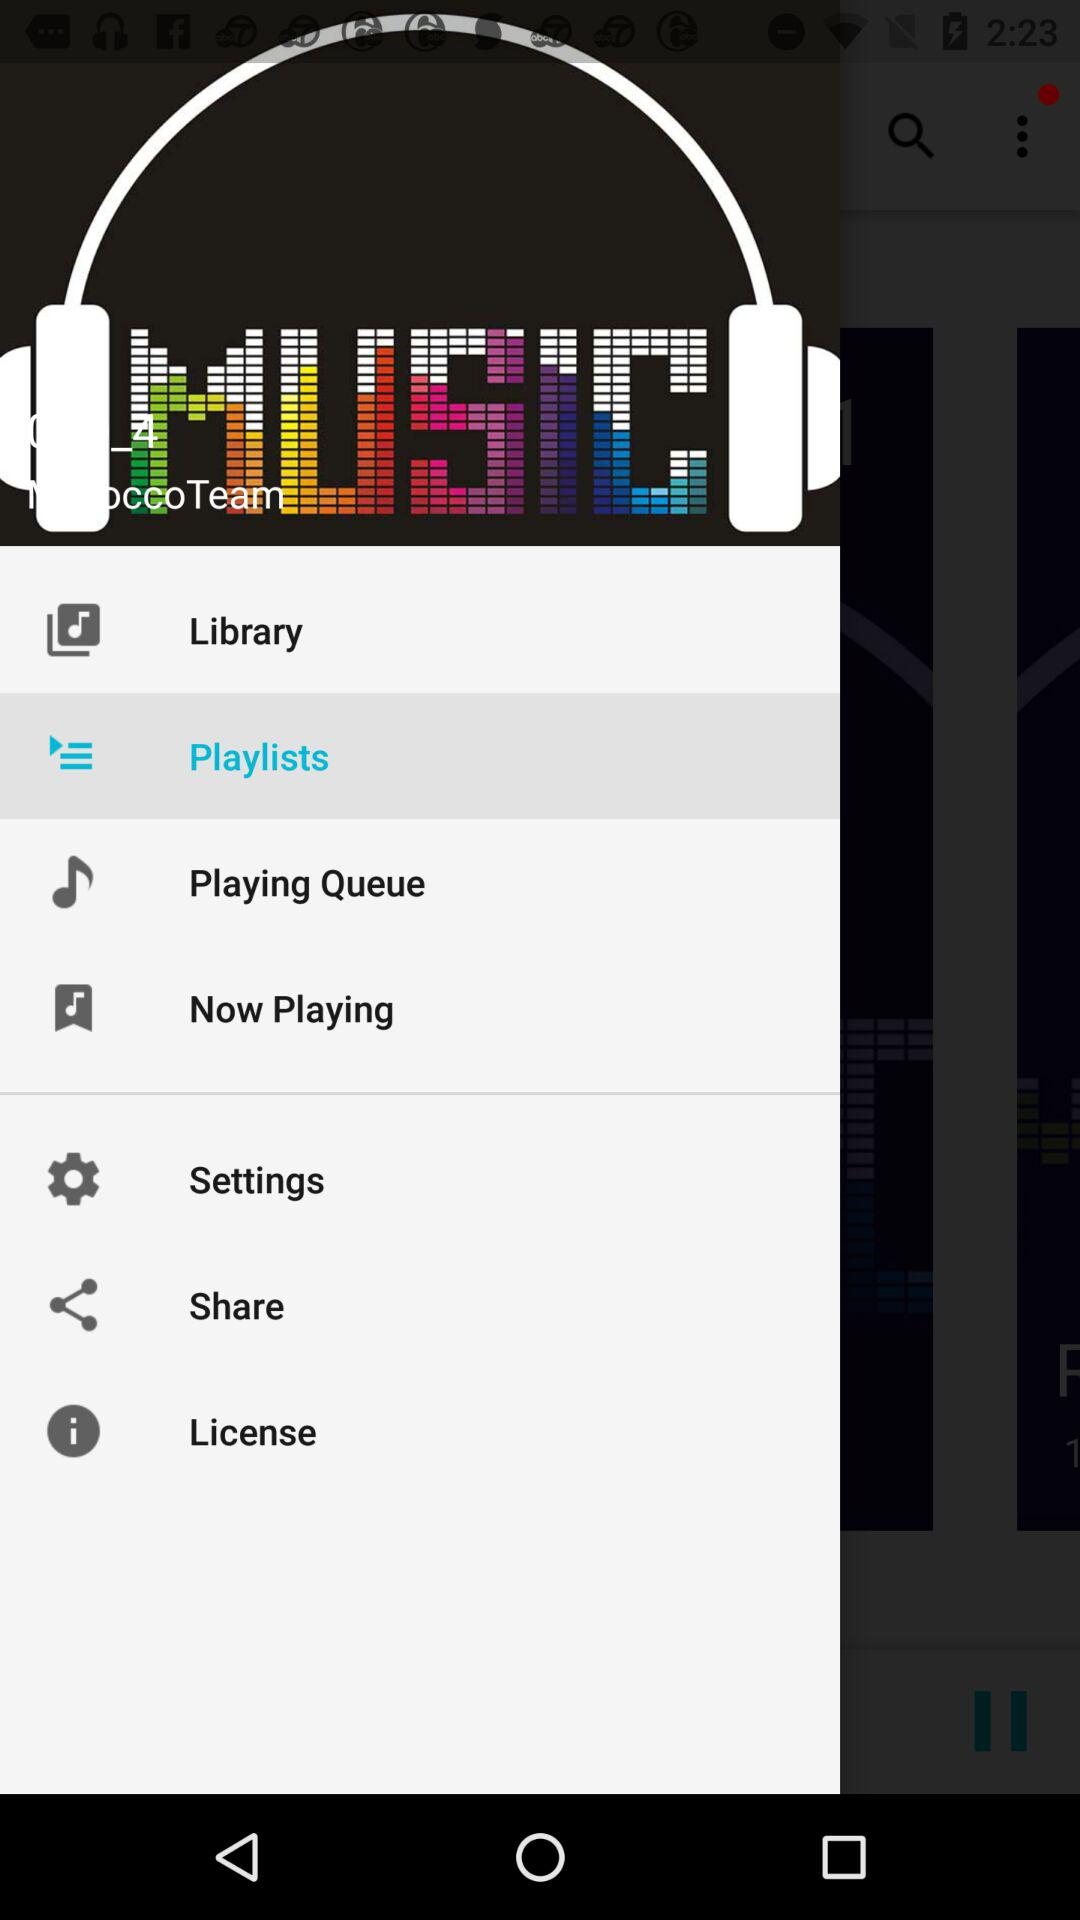Which applications are available for sharing the audio files?
When the provided information is insufficient, respond with <no answer>. <no answer> 